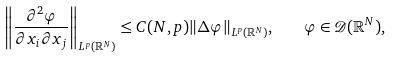<formula> <loc_0><loc_0><loc_500><loc_500>\left \| \frac { \partial ^ { 2 } \varphi } { \partial x _ { i } \partial x _ { j } } \right \| _ { L ^ { p } ( \mathbb { R } ^ { N } ) } \leq C ( N , p ) \| \Delta \varphi \| _ { L ^ { p } ( \mathbb { R } ^ { N } ) } , \quad \varphi \in { \mathcal { D } } ( \mathbb { R } ^ { N } ) ,</formula> 